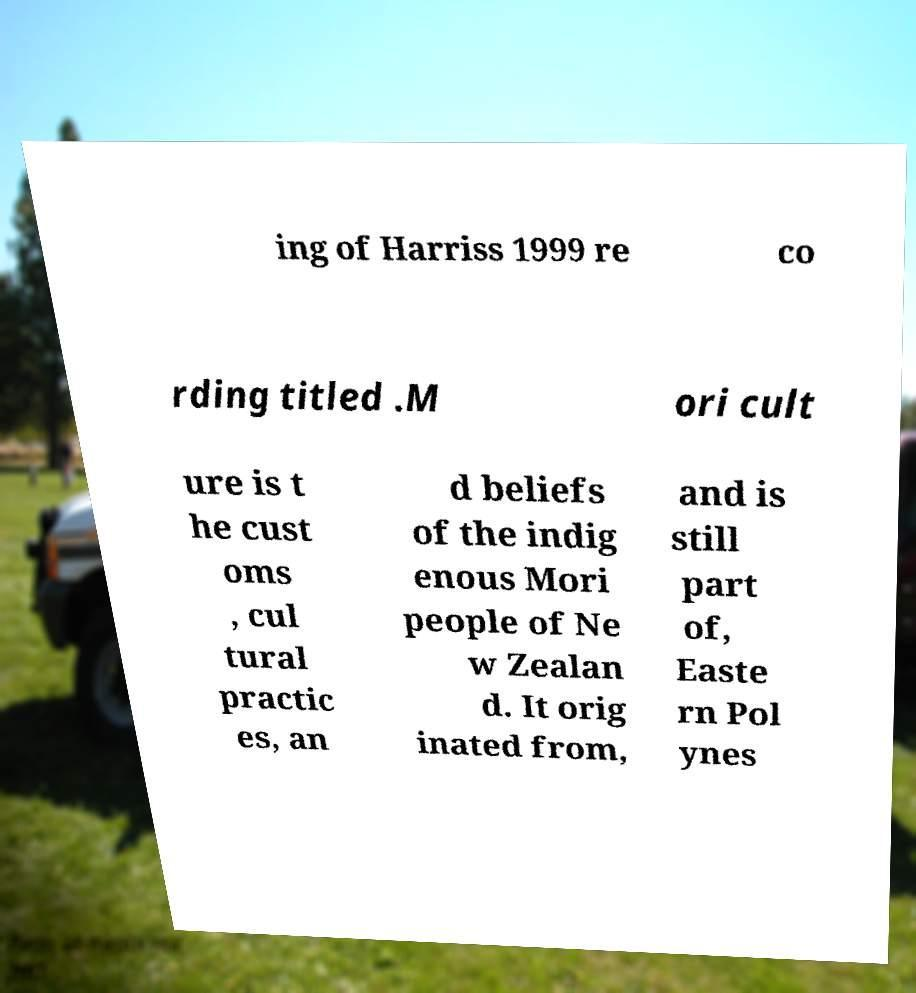For documentation purposes, I need the text within this image transcribed. Could you provide that? ing of Harriss 1999 re co rding titled .M ori cult ure is t he cust oms , cul tural practic es, an d beliefs of the indig enous Mori people of Ne w Zealan d. It orig inated from, and is still part of, Easte rn Pol ynes 